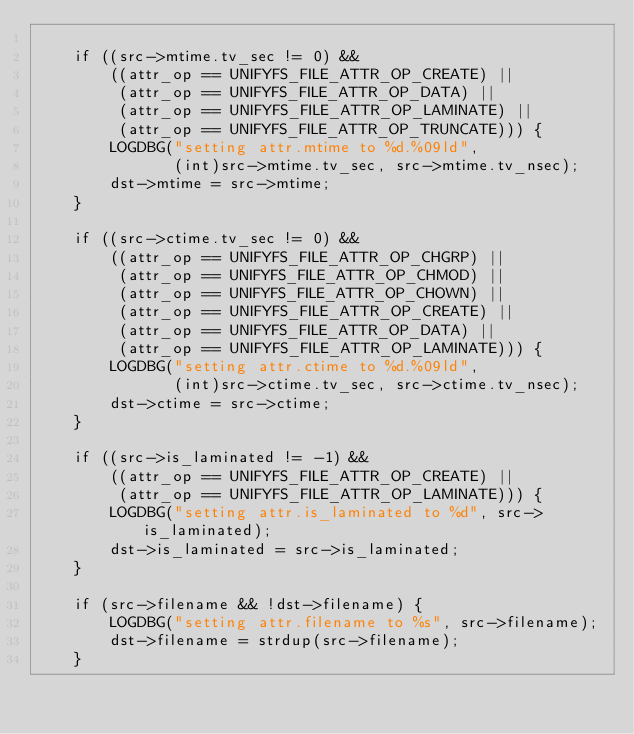Convert code to text. <code><loc_0><loc_0><loc_500><loc_500><_C_>
    if ((src->mtime.tv_sec != 0) &&
        ((attr_op == UNIFYFS_FILE_ATTR_OP_CREATE) ||
         (attr_op == UNIFYFS_FILE_ATTR_OP_DATA) ||
         (attr_op == UNIFYFS_FILE_ATTR_OP_LAMINATE) ||
         (attr_op == UNIFYFS_FILE_ATTR_OP_TRUNCATE))) {
        LOGDBG("setting attr.mtime to %d.%09ld",
               (int)src->mtime.tv_sec, src->mtime.tv_nsec);
        dst->mtime = src->mtime;
    }

    if ((src->ctime.tv_sec != 0) &&
        ((attr_op == UNIFYFS_FILE_ATTR_OP_CHGRP) ||
         (attr_op == UNIFYFS_FILE_ATTR_OP_CHMOD) ||
         (attr_op == UNIFYFS_FILE_ATTR_OP_CHOWN) ||
         (attr_op == UNIFYFS_FILE_ATTR_OP_CREATE) ||
         (attr_op == UNIFYFS_FILE_ATTR_OP_DATA) ||
         (attr_op == UNIFYFS_FILE_ATTR_OP_LAMINATE))) {
        LOGDBG("setting attr.ctime to %d.%09ld",
               (int)src->ctime.tv_sec, src->ctime.tv_nsec);
        dst->ctime = src->ctime;
    }

    if ((src->is_laminated != -1) &&
        ((attr_op == UNIFYFS_FILE_ATTR_OP_CREATE) ||
         (attr_op == UNIFYFS_FILE_ATTR_OP_LAMINATE))) {
        LOGDBG("setting attr.is_laminated to %d", src->is_laminated);
        dst->is_laminated = src->is_laminated;
    }

    if (src->filename && !dst->filename) {
        LOGDBG("setting attr.filename to %s", src->filename);
        dst->filename = strdup(src->filename);
    }
</code> 